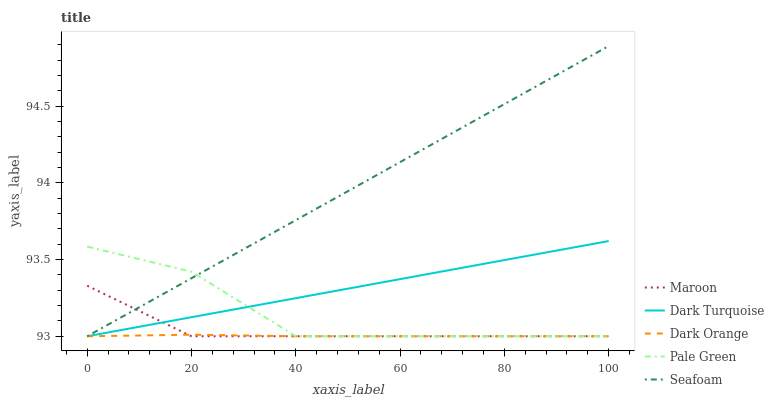Does Dark Orange have the minimum area under the curve?
Answer yes or no. Yes. Does Seafoam have the maximum area under the curve?
Answer yes or no. Yes. Does Pale Green have the minimum area under the curve?
Answer yes or no. No. Does Pale Green have the maximum area under the curve?
Answer yes or no. No. Is Dark Turquoise the smoothest?
Answer yes or no. Yes. Is Pale Green the roughest?
Answer yes or no. Yes. Is Seafoam the smoothest?
Answer yes or no. No. Is Seafoam the roughest?
Answer yes or no. No. Does Pale Green have the highest value?
Answer yes or no. No. 